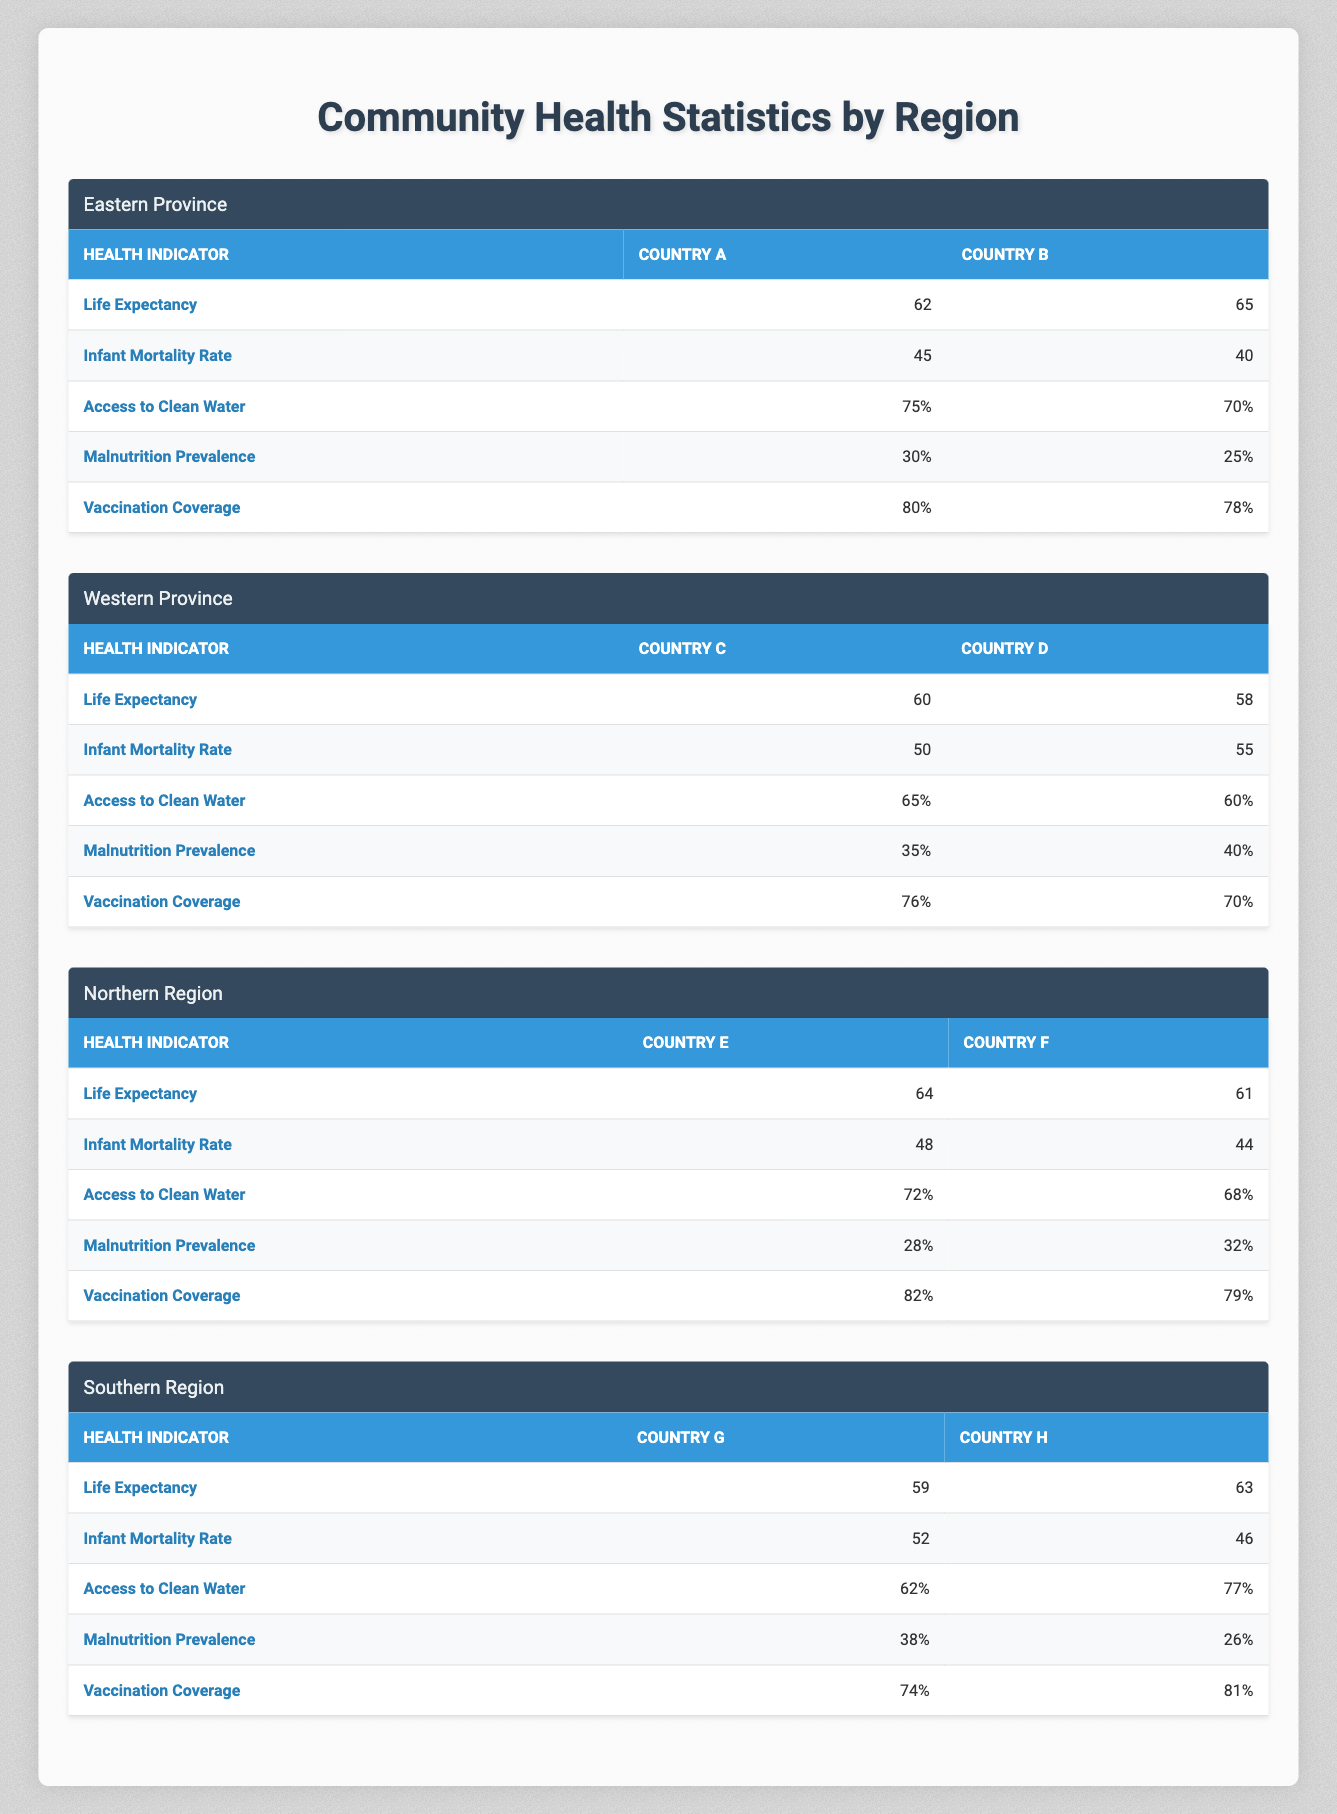What is the life expectancy in Country B? The table under the "Eastern Province" section shows that the life expectancy for Country B is reported as 65 years.
Answer: 65 Which country in the Western Province has a higher infant mortality rate? From the table, Country C has an infant mortality rate of 50, while Country D's rate is 55. Country D has a higher rate.
Answer: Country D What is the percentage of access to clean water in Country G? Looking at the Southern Region, Country G has 62% access to clean water as indicated in the relevant row of the table.
Answer: 62% What is the average life expectancy of countries in the Northern Region? For the Northern Region, Country E has a life expectancy of 64 and Country F has 61. The average can be calculated as (64 + 61) / 2 = 62.5.
Answer: 62.5 Is the malnutrition prevalence lower in Country H compared to Country G? The table indicates that Country H has a malnutrition prevalence of 26%, while Country G has 38%. Since 26% is lower than 38%, the answer is yes.
Answer: Yes Which region has the highest vaccination coverage and what is the value? Comparing the vaccination coverage across the regions, Eastern Province has 80%, Northern Region has 82%, Western Province has 76%, and Southern Region has 81%. The Northern Region has the highest coverage at 82%.
Answer: Northern Region, 82% What is the difference in access to clean water between Country E and Country F? From the Northern Region section, Country E has 72% access to clean water while Country F has 68%. The difference is 72 - 68 = 4%.
Answer: 4% In which region does Country D belong, and how does its access to clean water compare to Country A's? Country D is located in the Western Province, with 60% access to clean water. Country A, located in the Eastern Province, has 75%. Since 75% is greater than 60%, Country A has better access.
Answer: Western Province; Country A has better access What is the average infant mortality rate across the Eastern Province countries? The infant mortality rates for Country A and Country B are 45 and 40, respectively. The average is calculated as (45 + 40) / 2 = 42.5.
Answer: 42.5 